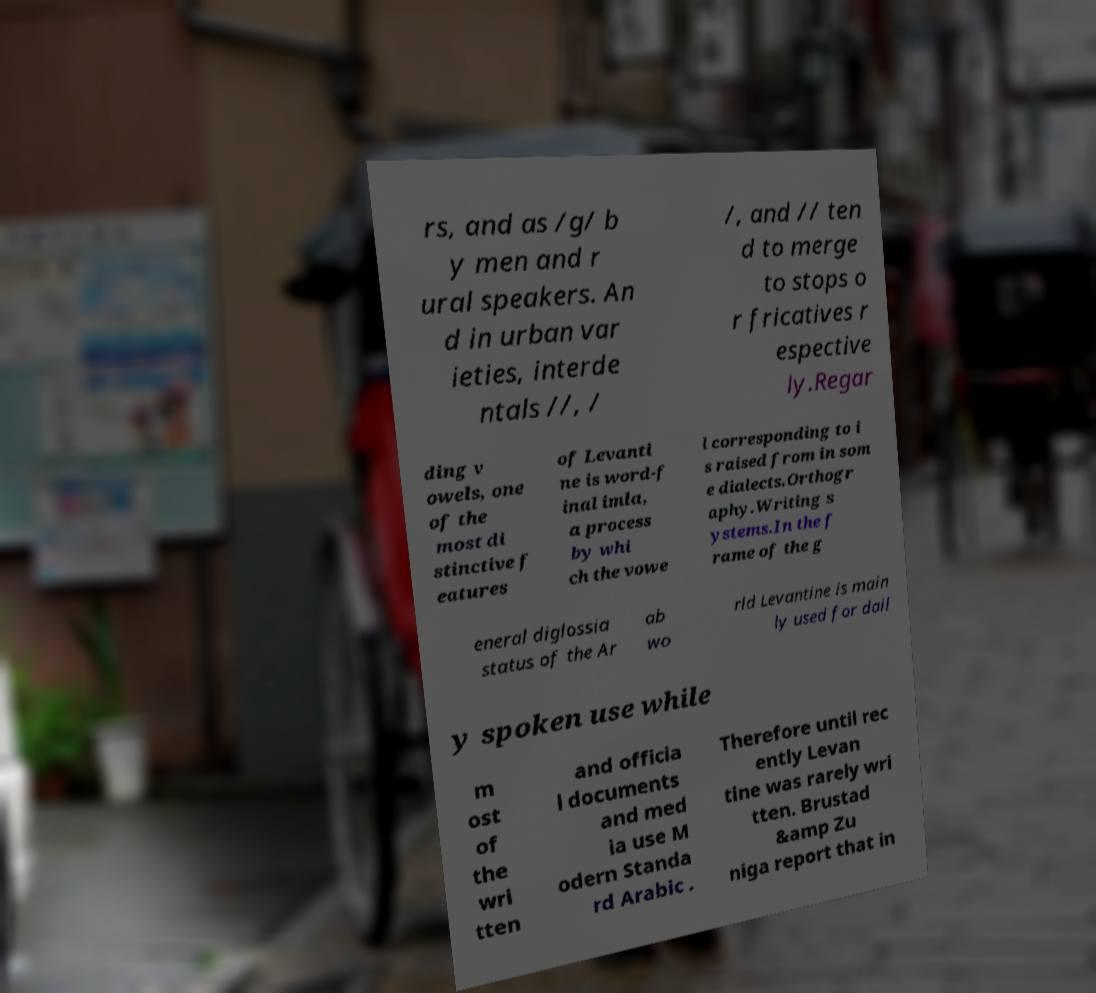Can you read and provide the text displayed in the image?This photo seems to have some interesting text. Can you extract and type it out for me? rs, and as /g/ b y men and r ural speakers. An d in urban var ieties, interde ntals //, / /, and // ten d to merge to stops o r fricatives r espective ly.Regar ding v owels, one of the most di stinctive f eatures of Levanti ne is word-f inal imla, a process by whi ch the vowe l corresponding to i s raised from in som e dialects.Orthogr aphy.Writing s ystems.In the f rame of the g eneral diglossia status of the Ar ab wo rld Levantine is main ly used for dail y spoken use while m ost of the wri tten and officia l documents and med ia use M odern Standa rd Arabic . Therefore until rec ently Levan tine was rarely wri tten. Brustad &amp Zu niga report that in 